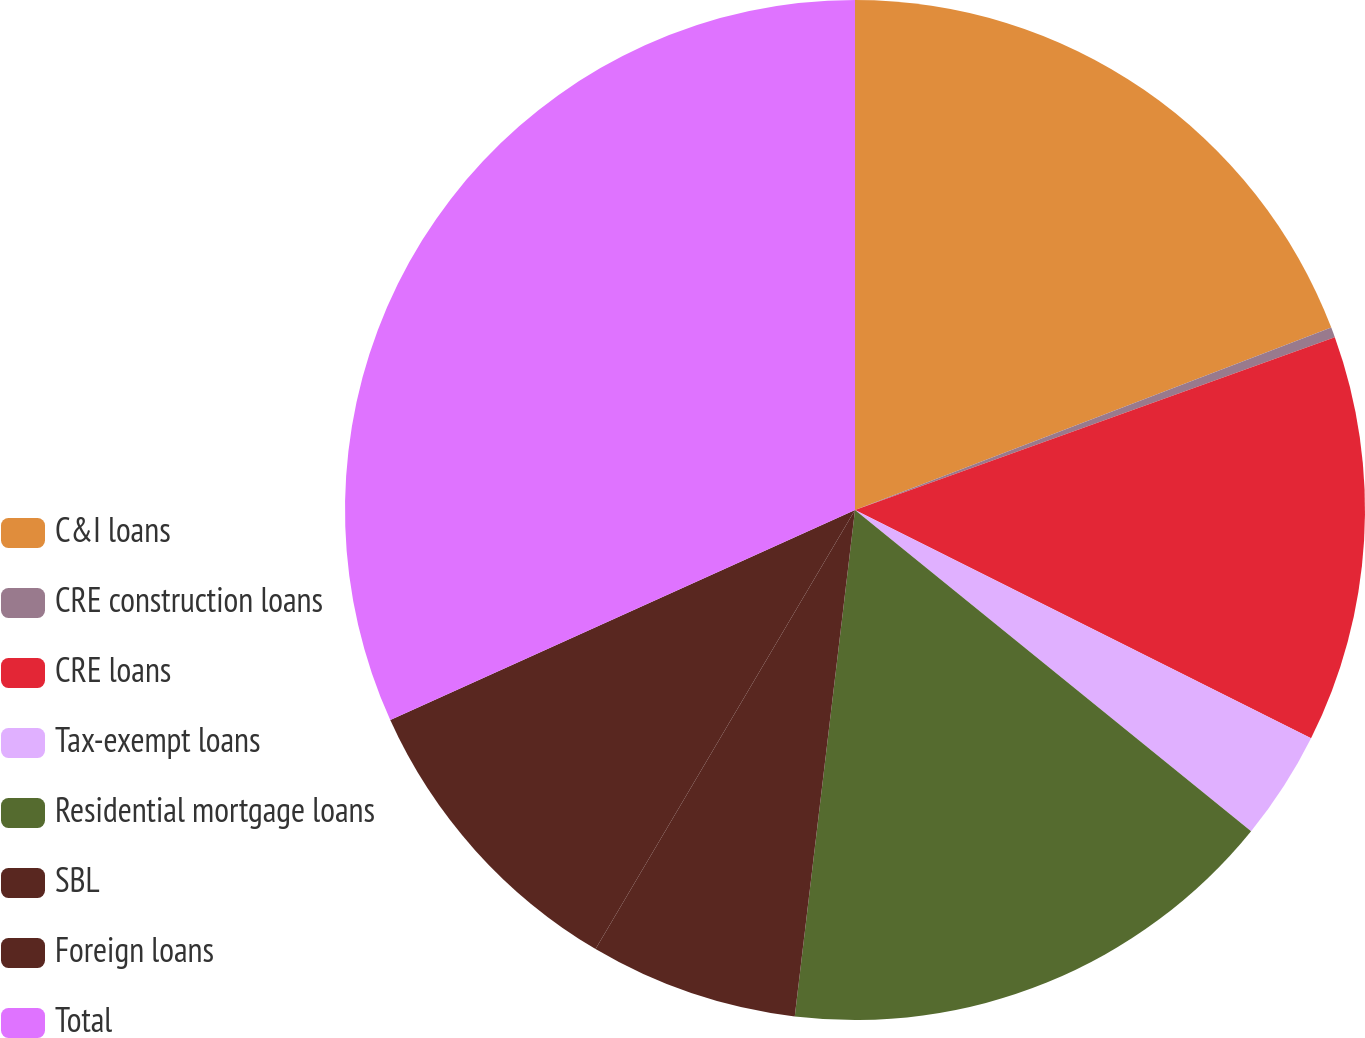Convert chart. <chart><loc_0><loc_0><loc_500><loc_500><pie_chart><fcel>C&I loans<fcel>CRE construction loans<fcel>CRE loans<fcel>Tax-exempt loans<fcel>Residential mortgage loans<fcel>SBL<fcel>Foreign loans<fcel>Total<nl><fcel>19.18%<fcel>0.32%<fcel>12.89%<fcel>3.46%<fcel>16.04%<fcel>6.61%<fcel>9.75%<fcel>31.76%<nl></chart> 